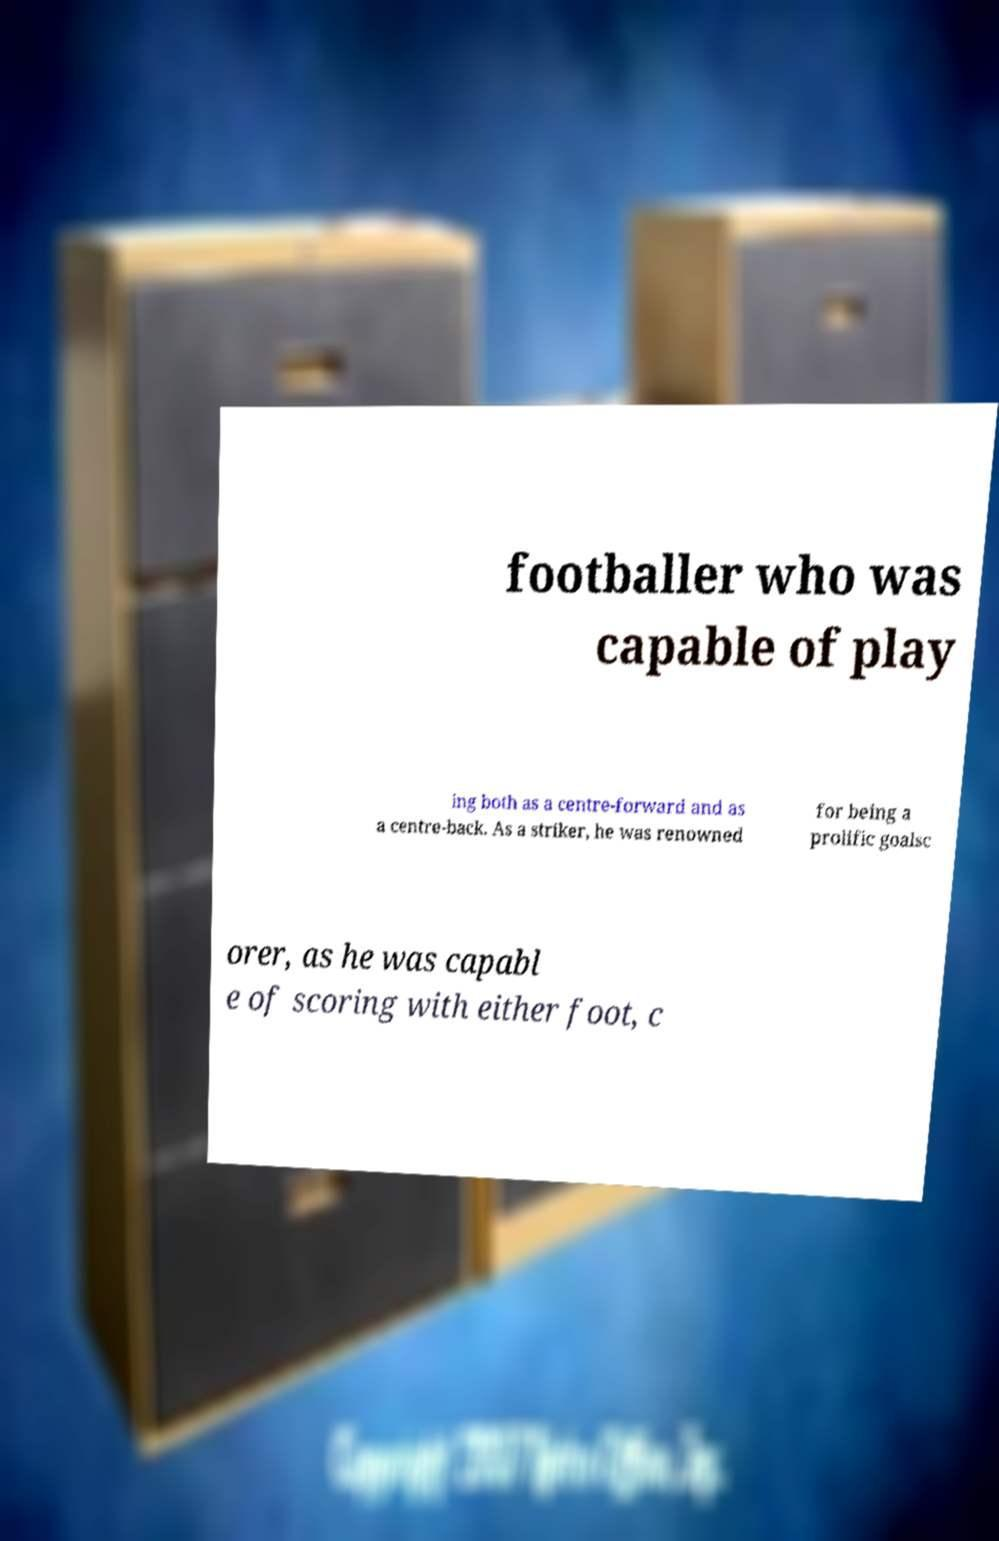What messages or text are displayed in this image? I need them in a readable, typed format. footballer who was capable of play ing both as a centre-forward and as a centre-back. As a striker, he was renowned for being a prolific goalsc orer, as he was capabl e of scoring with either foot, c 